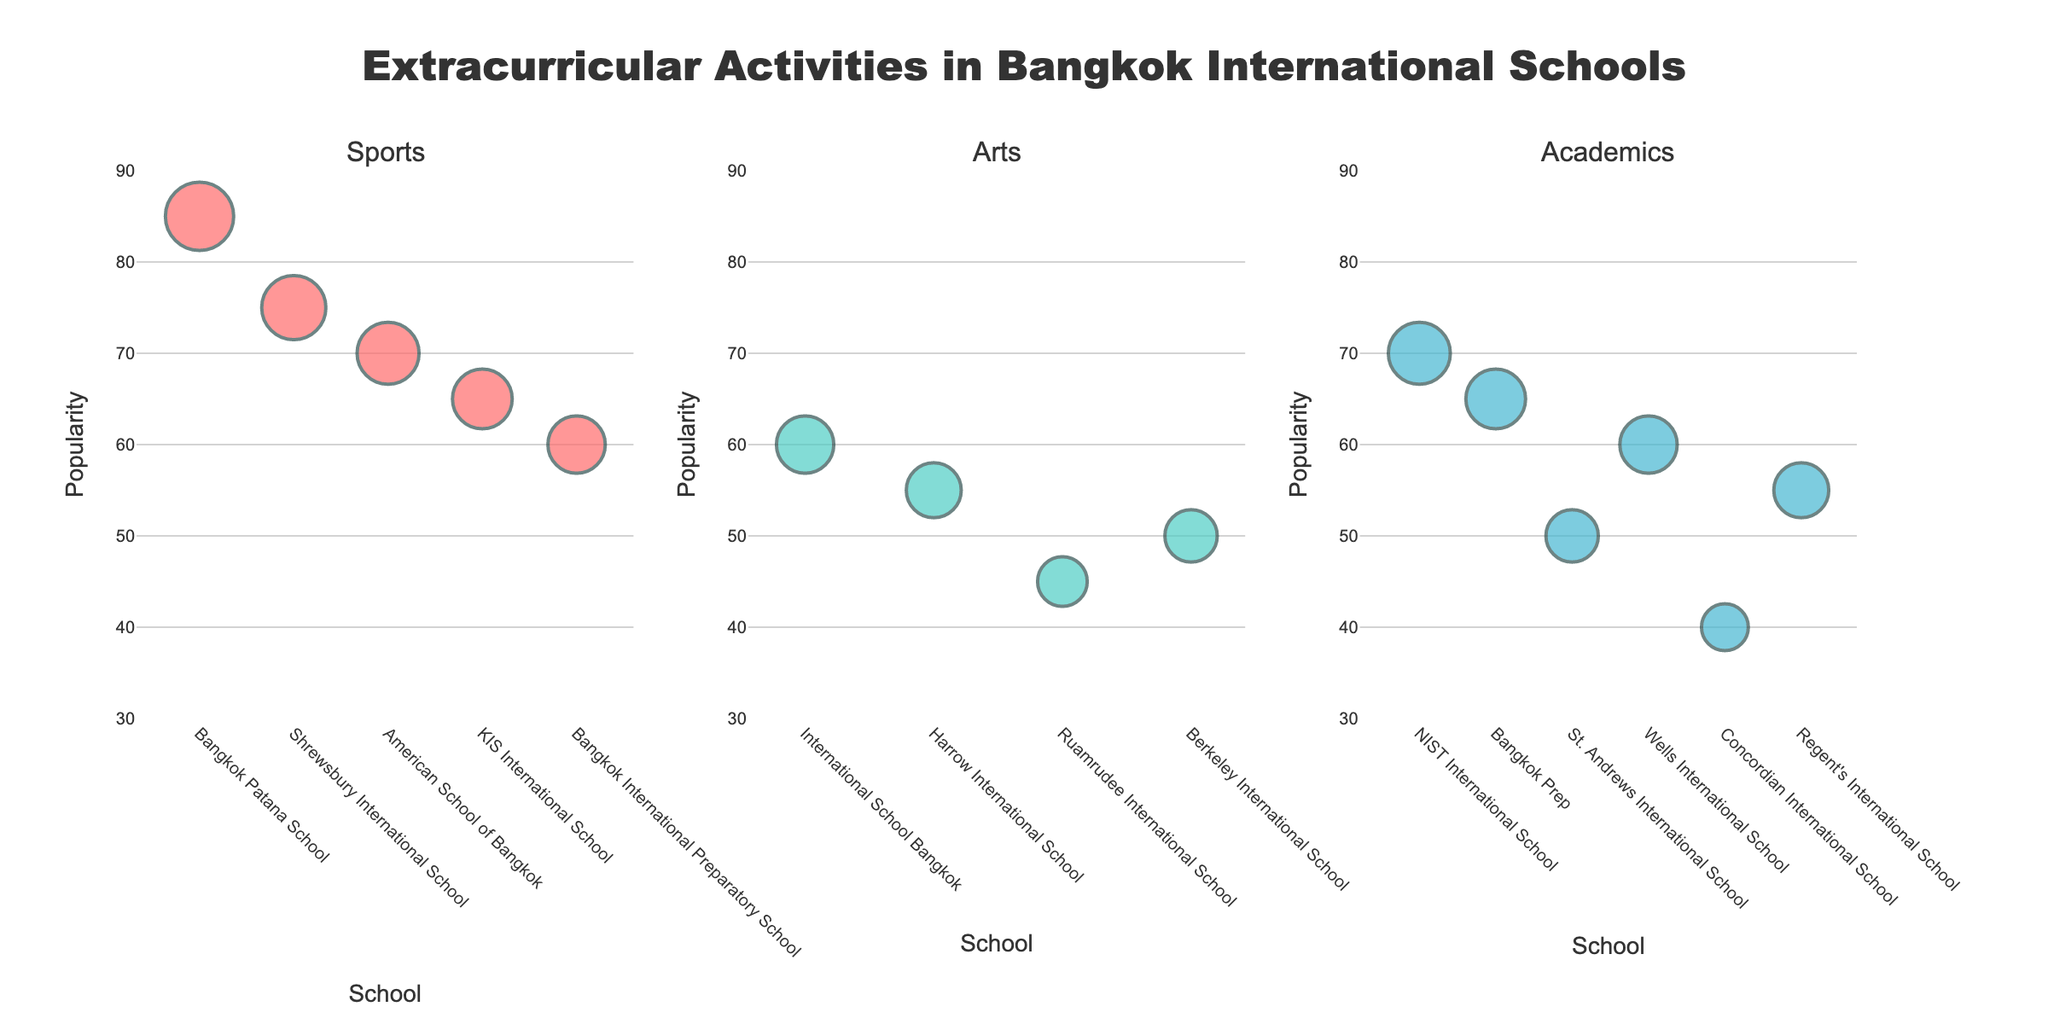What's the title of the figure? The title is usually displayed prominently at the top of the figure. In this case, it should summarize the content of the plots.
Answer: Distribution of Foreign Direct Investments by Sector in Emerging Markets Which country has the highest percentage of investment in a single sector? To find the highest single-sector investment, look for the largest piece of any pie chart. Vietnam's Electronics sector, which occupies 40%, is the largest.
Answer: Vietnam What is the total percentage of investment in Manufacturing and Financial Services in Brazil? Adding the percentages for Manufacturing (30%) and Financial Services (20%) in Brazil gives 30 + 20.
Answer: 50% How do Brazil and Indonesia compare in terms of their top investment sectors? Brazil's top sector is Manufacturing (30%), while Indonesia's top sector is Mining (30%). Both percentages are the same but in different industries.
Answer: Both have 30% in different sectors Which country has the most diversified investment across sectors? A more diversified investment would mean more evenly distributed percentages across sectors. Brazil shows a fairly even spread across 5 sectors compared to others.
Answer: Brazil In which country and sector is there the lowest percentage of investment? The lowest investment can be found by looking for the smallest segment of any pie chart. India's Retail sector has the lowest at 5%.
Answer: India, Retail What is the combined percentage of investment in the Automotive sector in India and Vietnam? Adding India's Automotive sector (20%) and Vietnam's Automotive sector (20%) gives 20 + 20 = 40%.
Answer: 40% What sectors are represented in Vietnam's investment? Each sector in Vietnam's pie chart represents a part of the investment. The sectors are Electronics, Textiles, Automotive, Renewable Energy, and Logistics.
Answer: Electronics, Textiles, Automotive, Renewable Energy, Logistics How does the percentage of investment in Real Estate in Brazil compare to Telecommunications in Indonesia? By directly comparing the percentages, Brazil's Real Estate (10%) is equal to Indonesia's Telecommunications (10%).
Answer: They are equal What sector receives the highest investment in India? Identifying the largest piece of India's pie chart points to the Information Technology sector, which has 35% investment.
Answer: Information Technology 